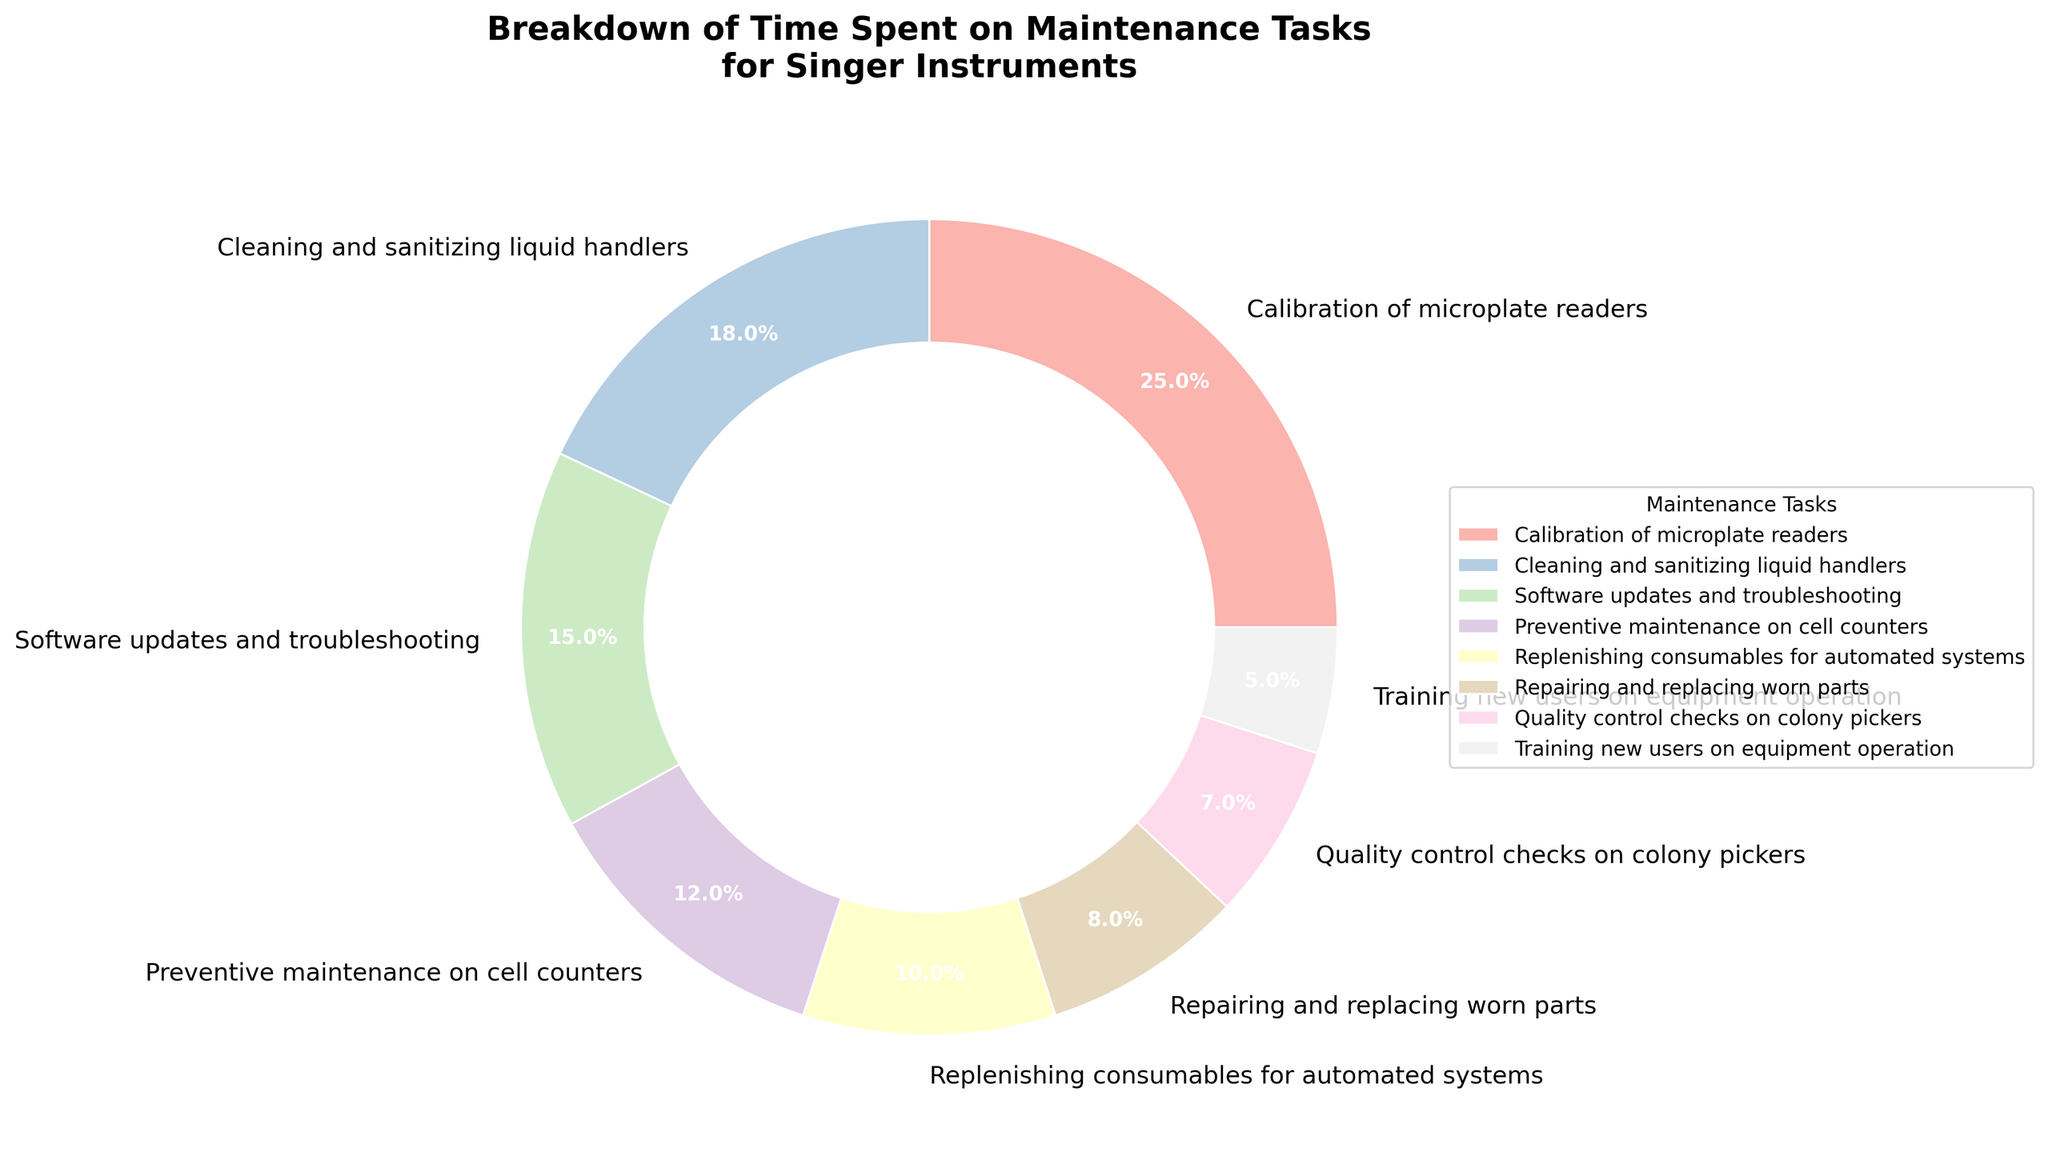Which maintenance task takes up the largest percentage of time? Look at the pie chart and identify the segment with the largest proportion. Calibration of microplate readers has the largest segment at 25%.
Answer: Calibration of microplate readers How much time in percentage is spent on calibration of microplate readers and cleaning and sanitizing liquid handlers combined? Find the percentages for calibration of microplate readers and cleaning and sanitizing liquid handlers, which are 25% and 18% respectively. Add these two percentages together: 25% + 18% = 43%.
Answer: 43% Which maintenance task takes the least amount of time? Identify the smallest segment in the pie chart. Training new users on equipment operation occupies the smallest segment at 5%.
Answer: Training new users on equipment operation How does the time spent on software updates and troubleshooting compare to time spent on repairing and replacing worn parts? The time spent on software updates and troubleshooting is 15%, whereas the time spent on repairing and replacing worn parts is 8%. Compare 15% and 8%, and notice that software updates and troubleshooting takes more time.
Answer: More time is spent on software updates and troubleshooting What is the average time percentage spent on cleaning and sanitizing liquid handlers, replenishing consumables for automated systems, and quality control checks on colony pickers? Find the percentages for each task: cleaning and sanitizing liquid handlers (18%), replenishing consumables for automated systems (10%), quality control checks on colony pickers (7%). Then calculate the average: (18% + 10% + 7%) / 3 = 11.67%.
Answer: 11.67% Is more time spent on preventive maintenance on cell counters or on software updates and troubleshooting? Compare the percentages for preventive maintenance on cell counters (12%) and software updates and troubleshooting (15%). Software updates and troubleshooting take more time since 15% > 12%.
Answer: Software updates and troubleshooting What is the total time percentage spent on tasks related to direct equipment maintenance (calibration, cleaning, preventive maintenance, repairing and replacing parts)? Identify the percentages for calibration of microplate readers (25%), cleaning and sanitizing liquid handlers (18%), preventive maintenance on cell counters (12%), and repairing and replacing worn parts (8%). Add these together: 25% + 18% + 12% + 8% = 63%.
Answer: 63% Which task has almost half the percentage time of software updates and troubleshooting? Software updates and troubleshooting account for 15%. Identify the task close to half of 15%, which is roughly 7.5%. Quality control checks on colony pickers at 7% is the closest to half of 15%.
Answer: Quality control checks on colony pickers 